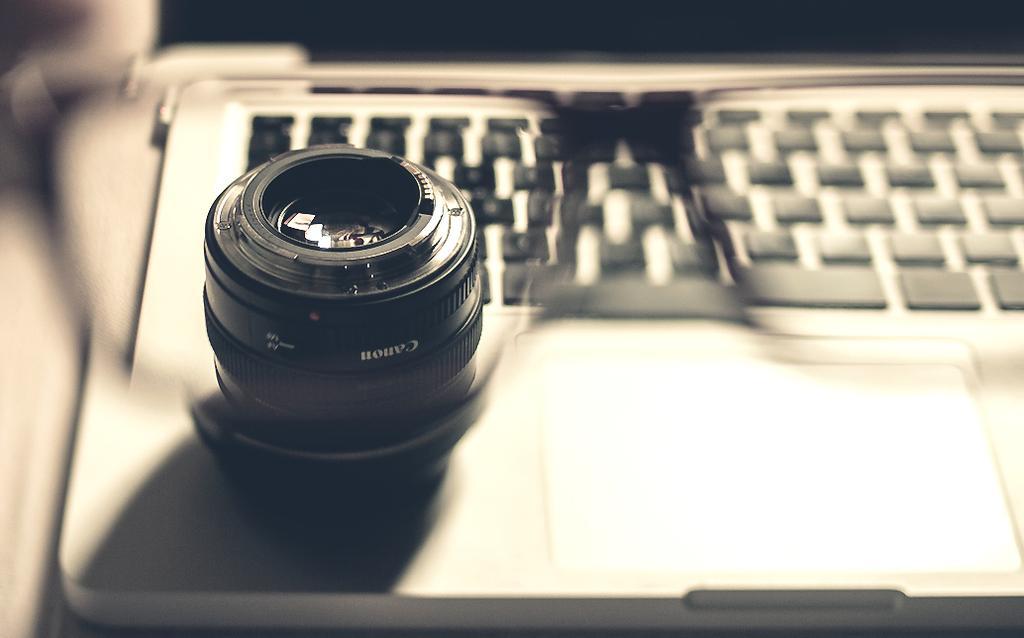How would you summarize this image in a sentence or two? There is a spectacles through which we can see a camera and a laptop. 